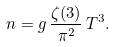Convert formula to latex. <formula><loc_0><loc_0><loc_500><loc_500>n = g \, \frac { \zeta ( 3 ) } { \pi ^ { 2 } } \, T ^ { 3 } .</formula> 